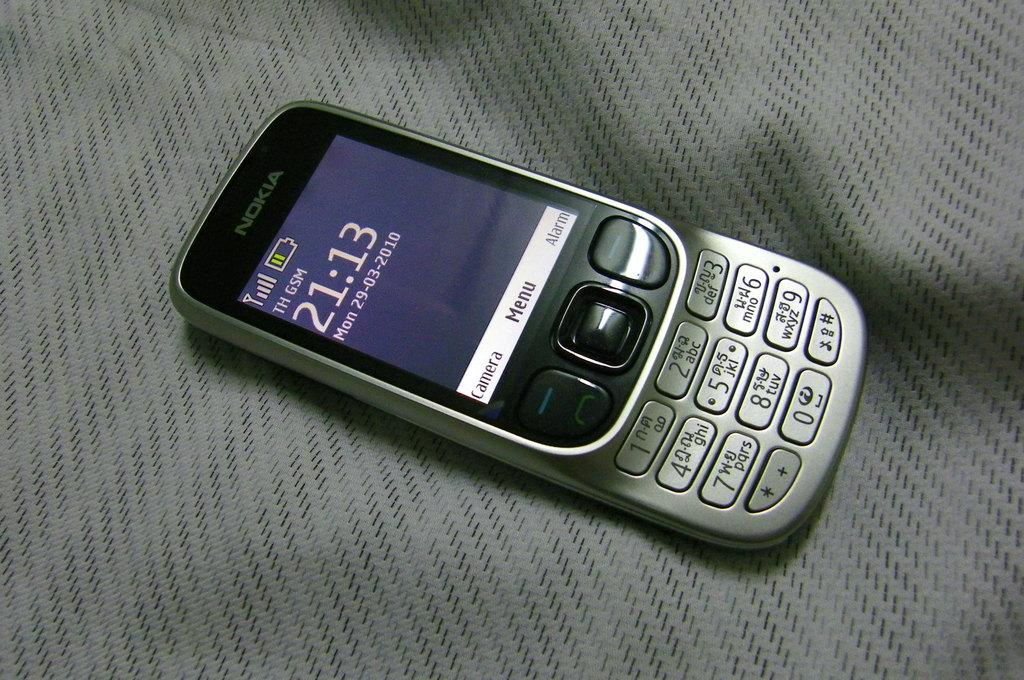<image>
Present a compact description of the photo's key features. An old Nokia phone displays the time 21:13 on its screen. 